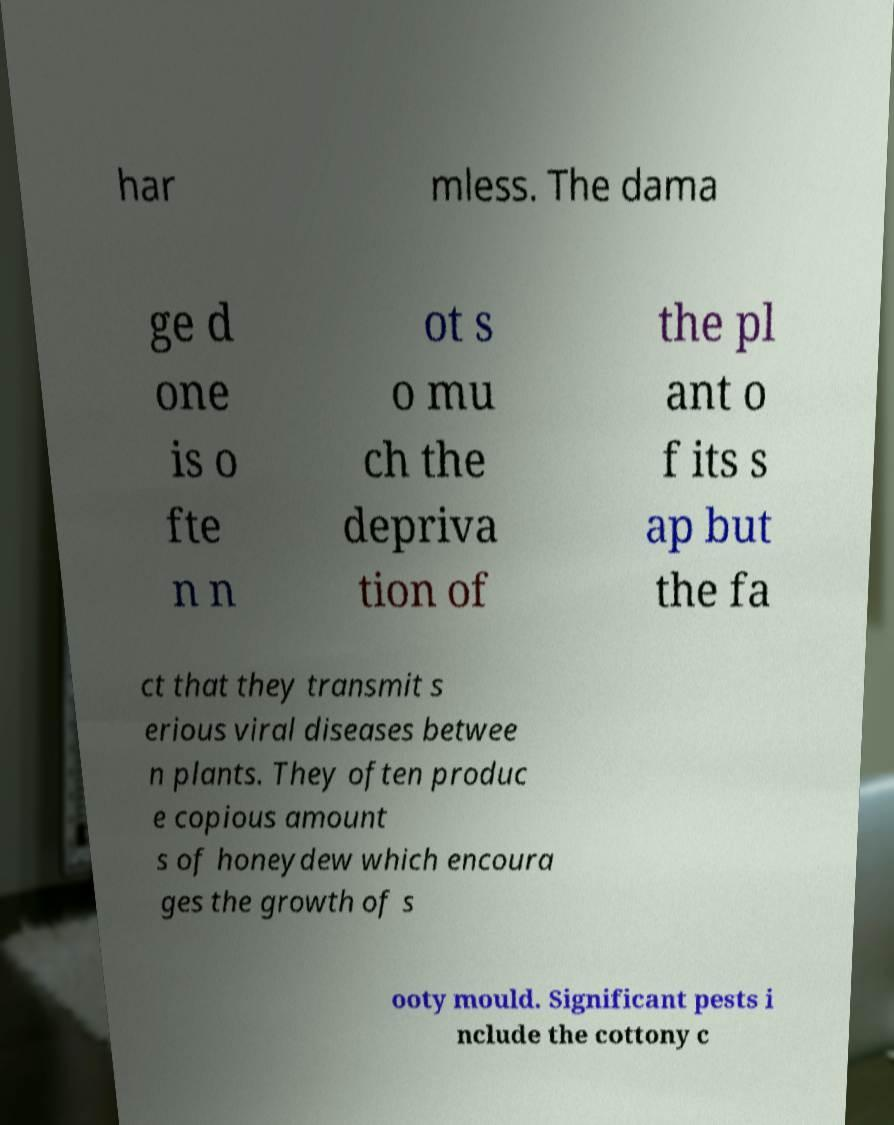Please identify and transcribe the text found in this image. har mless. The dama ge d one is o fte n n ot s o mu ch the depriva tion of the pl ant o f its s ap but the fa ct that they transmit s erious viral diseases betwee n plants. They often produc e copious amount s of honeydew which encoura ges the growth of s ooty mould. Significant pests i nclude the cottony c 